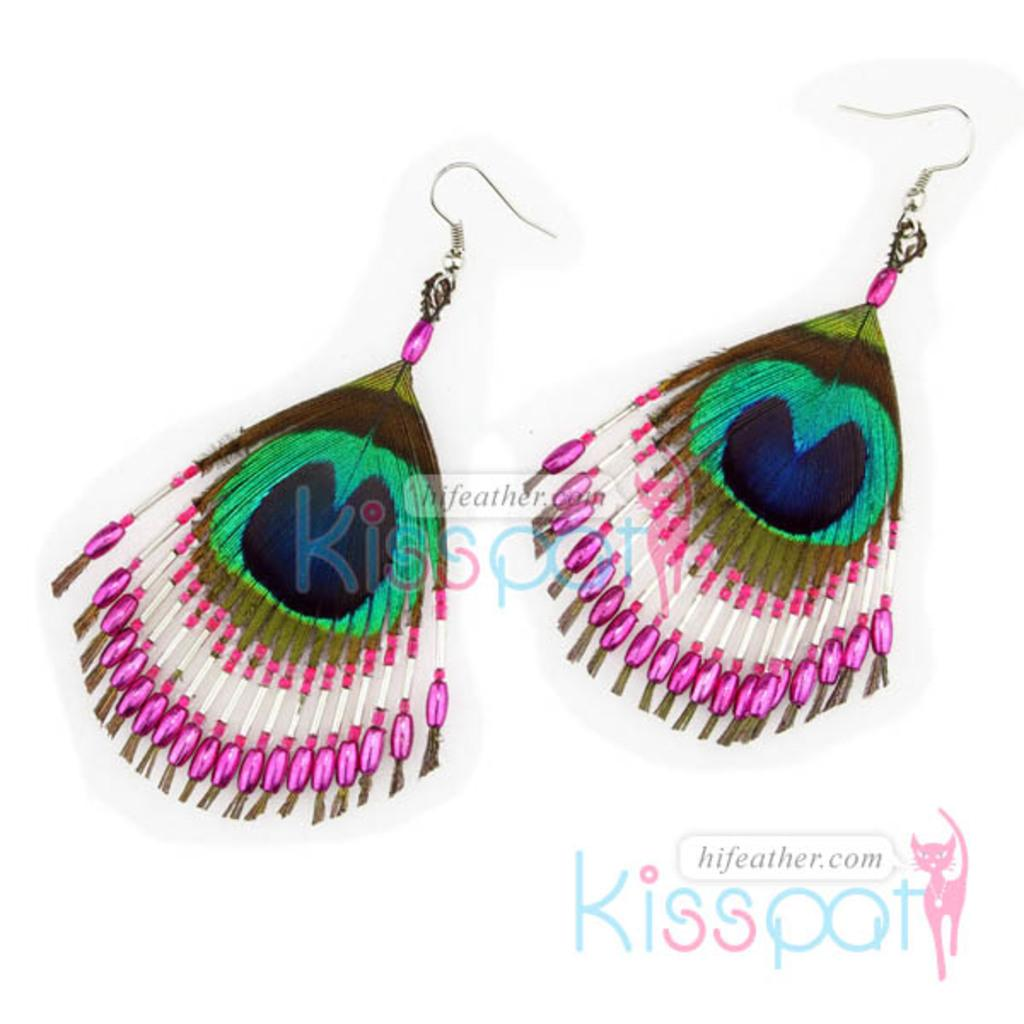What type of jewelry is featured in the image? There are two earrings in the image. What are the earrings made of? The earrings are made of peacock features. Are there any additional decorative elements on the earrings? Yes, the earrings have beads. What type of alarm can be seen in the image? There is no alarm present in the image; it features two earrings made of peacock features with beads. Can you tell me how many notebooks are visible in the image? There are no notebooks present in the image. 